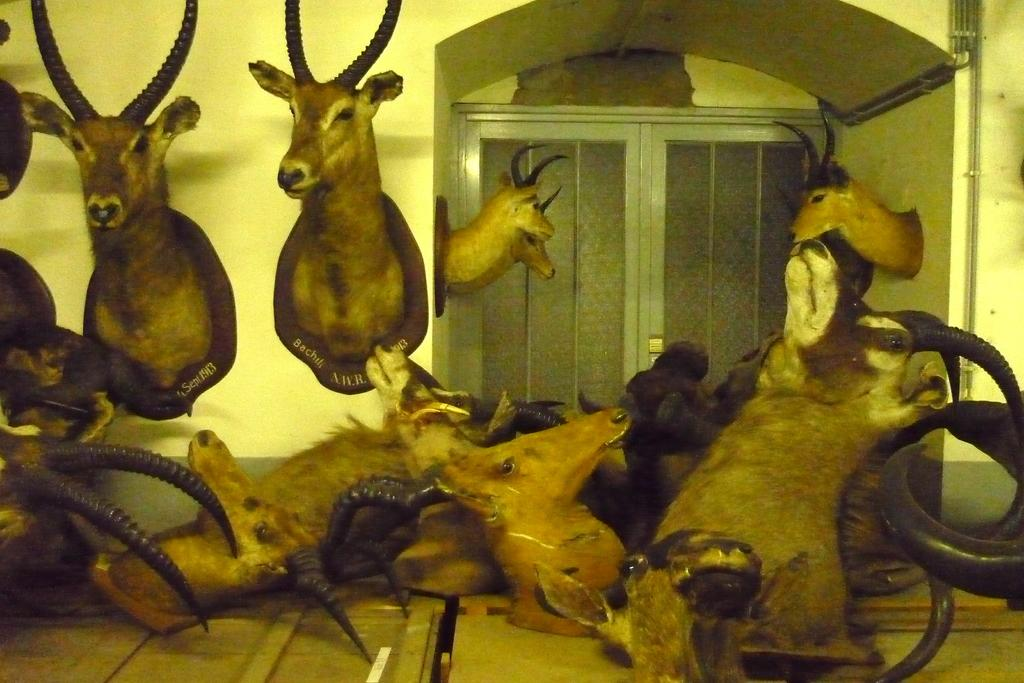What type of sculpture can be seen in the image? There is a sculpture of a goat in the image. How is the goat sculpture positioned in the room? The goat sculpture is fixed to the wall. Are there any other sculptures in the room besides the goat sculpture? Yes, there are multiple sculptures in the room. What can be seen in the background of the image? There is a door visible in the background of the image. What type of cheese is being used to maintain the health of the goat sculpture in the image? There is no cheese or health-related information about the goat sculpture in the image. 